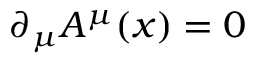Convert formula to latex. <formula><loc_0><loc_0><loc_500><loc_500>\partial _ { \mu } A ^ { \mu } ( x ) = 0</formula> 